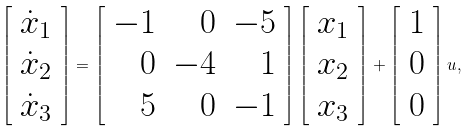Convert formula to latex. <formula><loc_0><loc_0><loc_500><loc_500>\left [ \begin{array} { c } \dot { x } _ { 1 } \\ \dot { x } _ { 2 } \\ \dot { x } _ { 3 } \end{array} \right ] = \left [ \begin{array} { r r r } - 1 & 0 & - 5 \\ 0 & - 4 & 1 \\ 5 & 0 & - 1 \end{array} \right ] \left [ \begin{array} { c } x _ { 1 } \\ x _ { 2 } \\ x _ { 3 } \end{array} \right ] + \left [ \begin{array} { c } 1 \\ 0 \\ 0 \end{array} \right ] u ,</formula> 